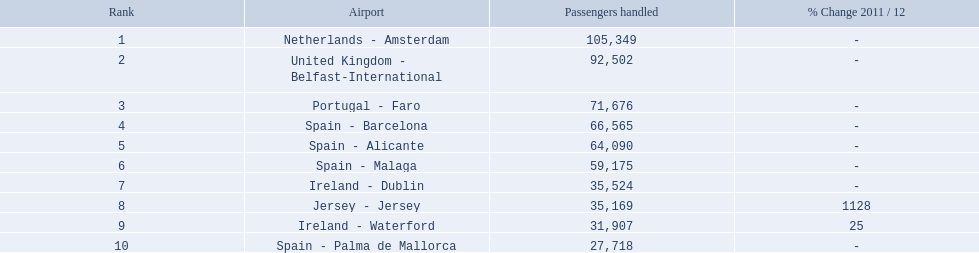What is the best rank? 1. What is the airport? Netherlands - Amsterdam. 